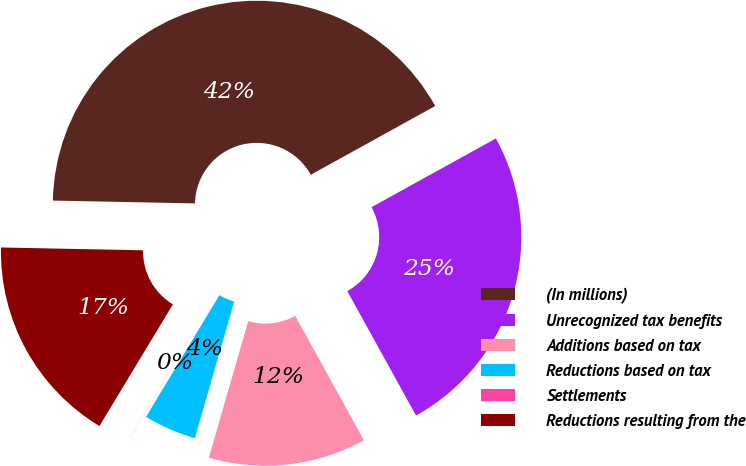Convert chart to OTSL. <chart><loc_0><loc_0><loc_500><loc_500><pie_chart><fcel>(In millions)<fcel>Unrecognized tax benefits<fcel>Additions based on tax<fcel>Reductions based on tax<fcel>Settlements<fcel>Reductions resulting from the<nl><fcel>41.65%<fcel>25.0%<fcel>12.5%<fcel>4.17%<fcel>0.01%<fcel>16.67%<nl></chart> 